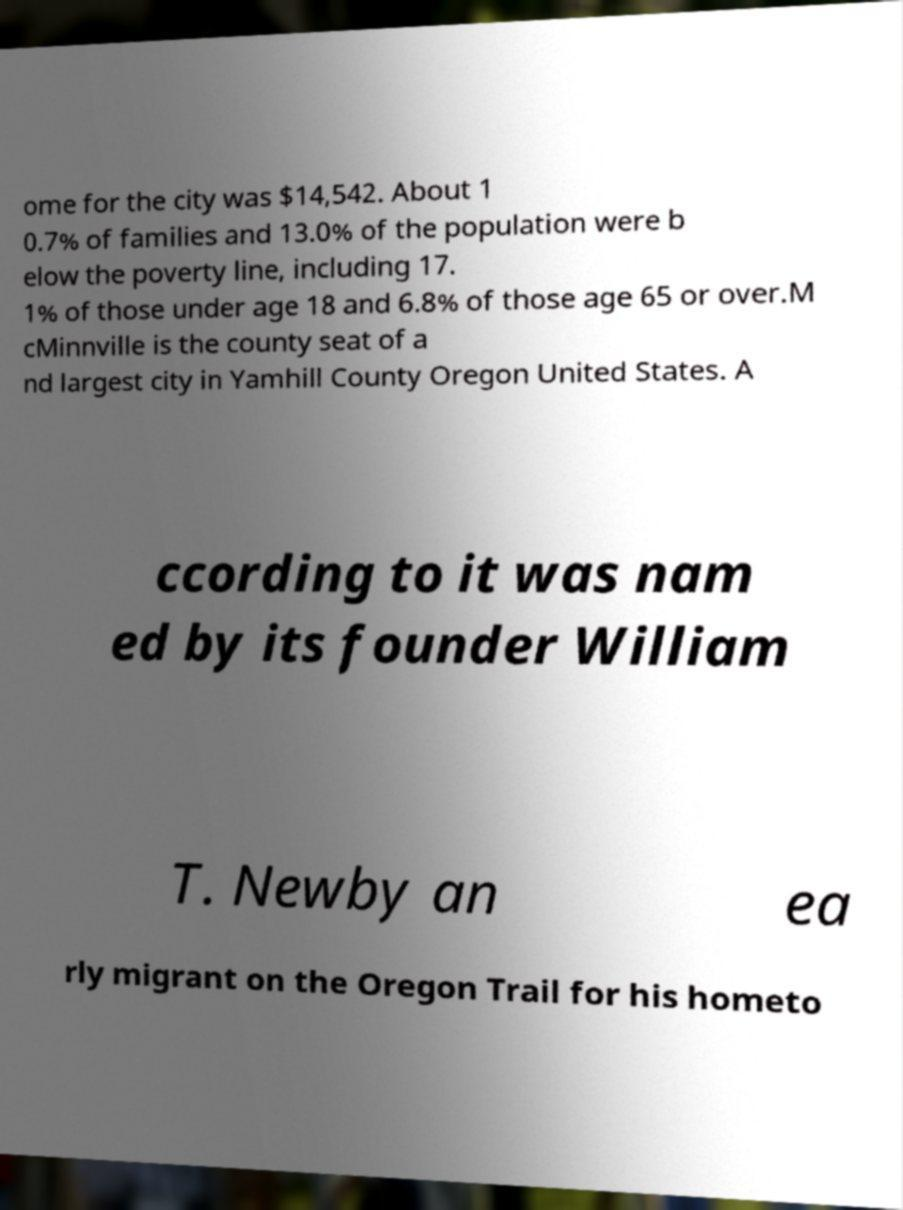Please read and relay the text visible in this image. What does it say? ome for the city was $14,542. About 1 0.7% of families and 13.0% of the population were b elow the poverty line, including 17. 1% of those under age 18 and 6.8% of those age 65 or over.M cMinnville is the county seat of a nd largest city in Yamhill County Oregon United States. A ccording to it was nam ed by its founder William T. Newby an ea rly migrant on the Oregon Trail for his hometo 